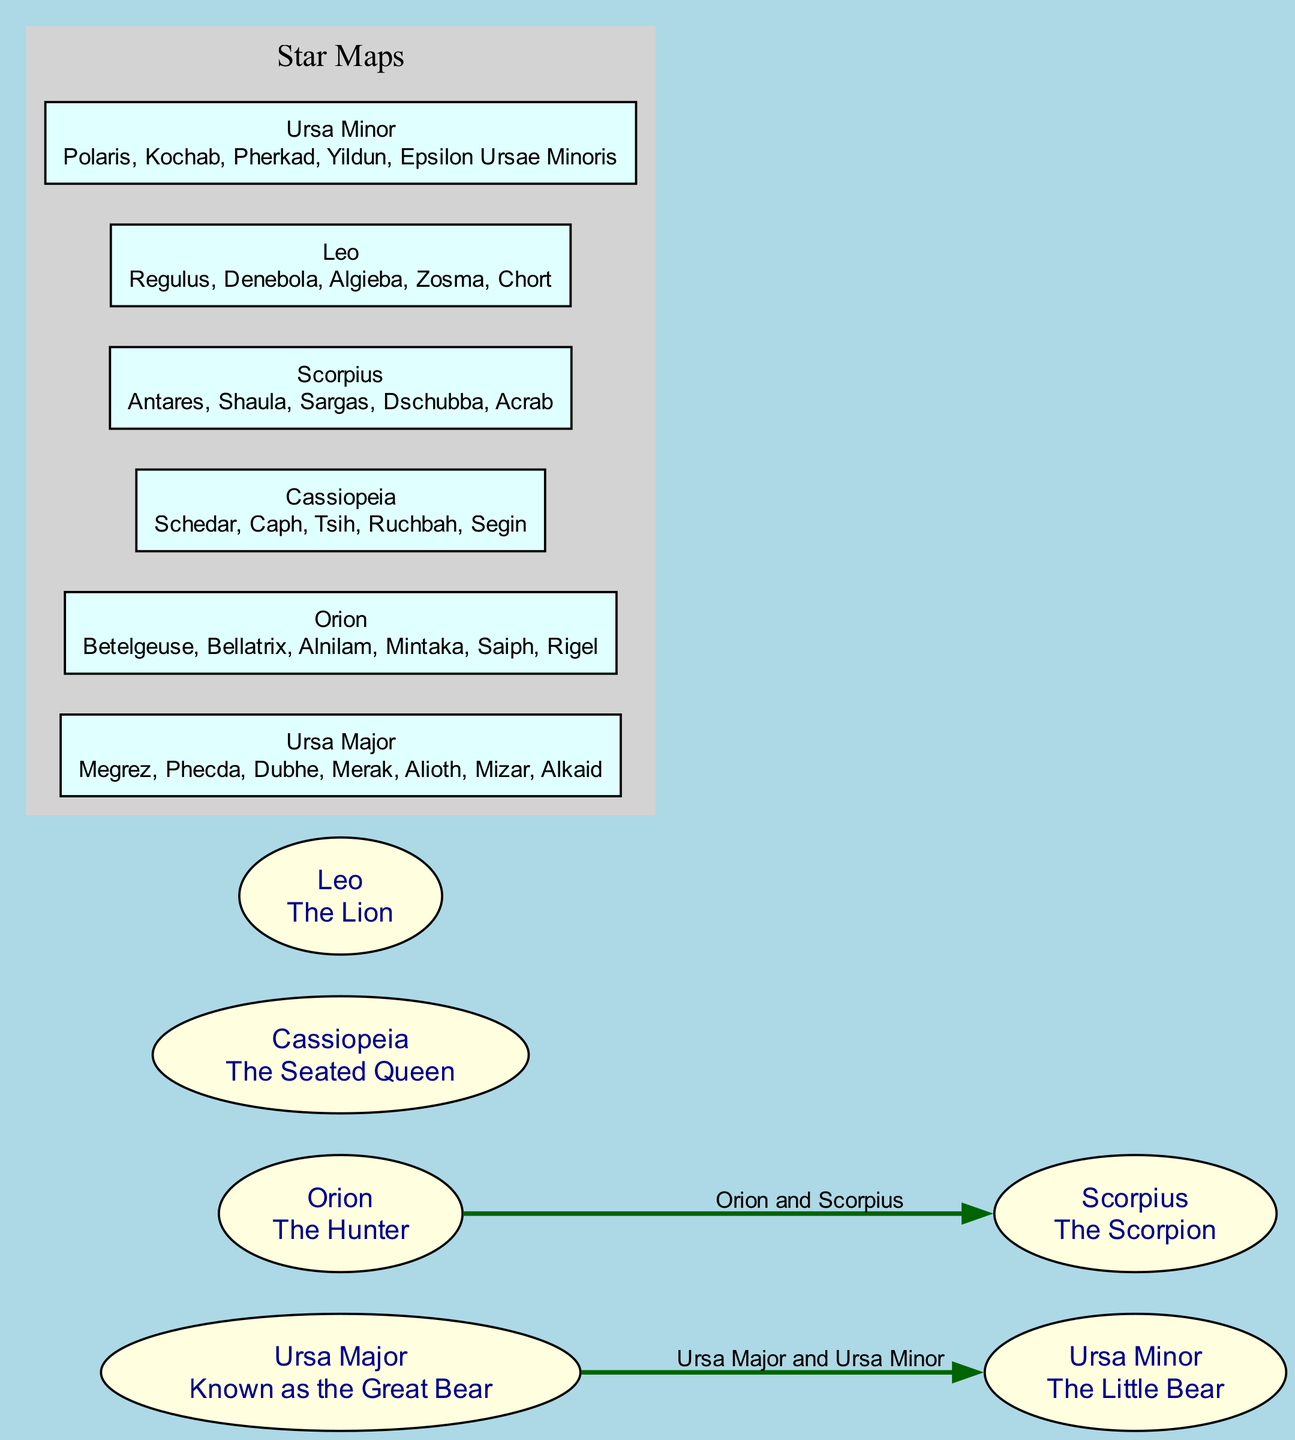What is the mythology associated with Ursa Major? Ursa Major is associated with Greek mythology, particularly known for the Big Dipper asterism. This information can be found in the description of Ursa Major included in the diagram's elements.
Answer: Greek mythology, Big Dipper How many stars are listed for Cassiopeia? The star map under Cassiopeia lists five stars: Schedar, Caph, Tsih, Ruchbah, and Segin. Counting these stars would give us the total number.
Answer: 5 Which two constellations are connected by the chase myth? The connection label indicates that Orion and Scorpius are linked through the myth where Orion is chased by Scorpius, as demonstrated in the connections section of the diagram.
Answer: Orion and Scorpius What shape is notable for the constellation Cassiopeia? The description of Cassiopeia mentions its distinctive 'W' shape. This information provides a key identifier for this constellation in the diagram.
Answer: 'W' shape Which constellation contains Polaris? The description of Ursa Minor highlights that it contains Polaris, also known as the North Star. This key detail is included in the elements associated with Ursa Minor.
Answer: Ursa Minor How are Ursa Major and Ursa Minor related? The diagram notes that both Ursa Major and Ursa Minor are associated with bears in Greek mythology and are located in the northern sky, which indicates their close thematic connection.
Answer: Associated with bears Identify one star from the Leo constellation. The star map for Leo includes multiple stars, including Regulus, which was specifically mentioned as part of the listed stars in the corresponding section of the diagram.
Answer: Regulus What is the description of Orion? According to the diagram, Orion is described as "The Hunter", which is part of the elemental information provided in the diagram.
Answer: The Hunter How many connections are shown in the diagram? By reviewing the connections section, we can count two connections made between different constellations, thus giving the total number of connections.
Answer: 2 